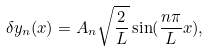<formula> <loc_0><loc_0><loc_500><loc_500>\delta y _ { n } ( x ) = A _ { n } \sqrt { \frac { 2 } { L } } \sin ( \frac { n \pi } L x ) ,</formula> 